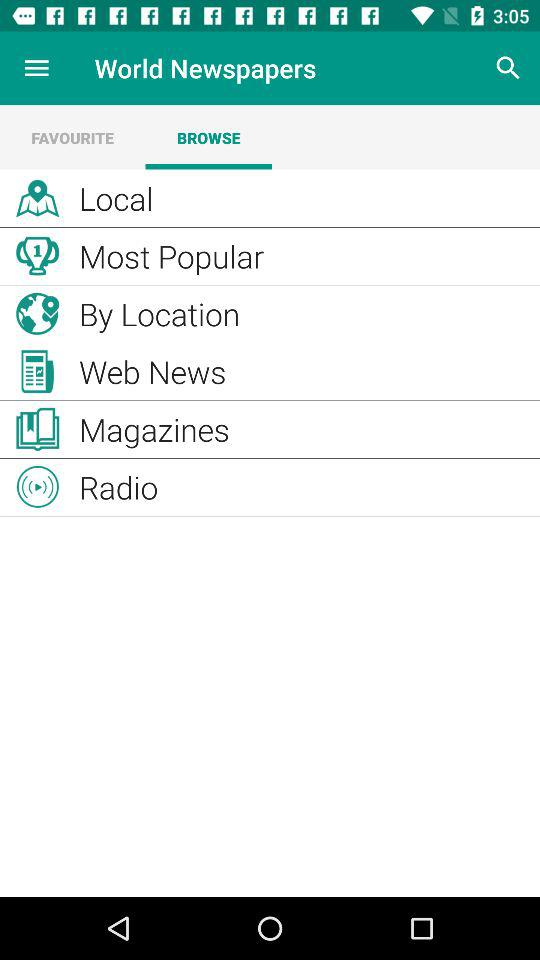What is the application name? The application name is "World Newspapers". 